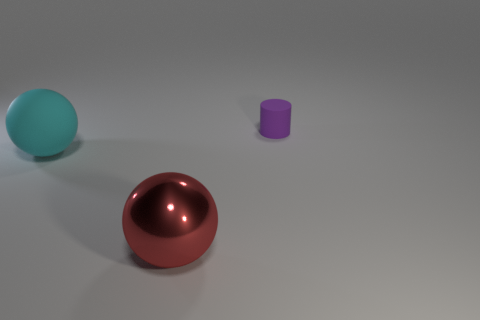What are the sizes of the objects in relation to each other? The red ball in the foreground appears to be the largest object, followed by the cyan sphere which is slightly smaller. The purple cylinder looks to be the smallest in size. 